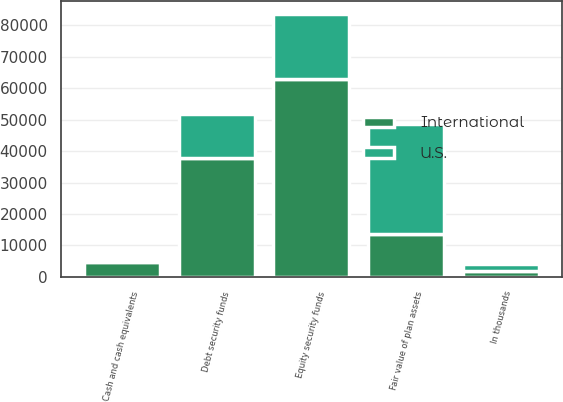<chart> <loc_0><loc_0><loc_500><loc_500><stacked_bar_chart><ecel><fcel>In thousands<fcel>Equity security funds<fcel>Debt security funds<fcel>Cash and cash equivalents<fcel>Fair value of plan assets<nl><fcel>U.S.<fcel>2009<fcel>20735<fcel>13755<fcel>382<fcel>34872<nl><fcel>International<fcel>2009<fcel>62901<fcel>37958<fcel>4642<fcel>13755<nl></chart> 